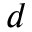<formula> <loc_0><loc_0><loc_500><loc_500>d</formula> 